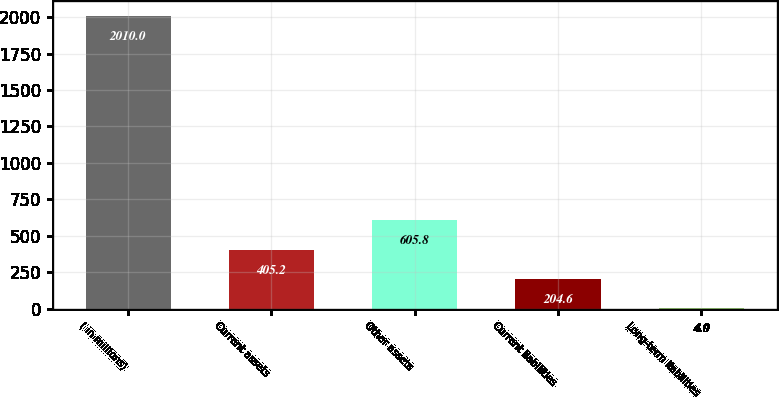Convert chart. <chart><loc_0><loc_0><loc_500><loc_500><bar_chart><fcel>( in millions)<fcel>Current assets<fcel>Other assets<fcel>Current liabilities<fcel>Long-term liabilities<nl><fcel>2010<fcel>405.2<fcel>605.8<fcel>204.6<fcel>4<nl></chart> 